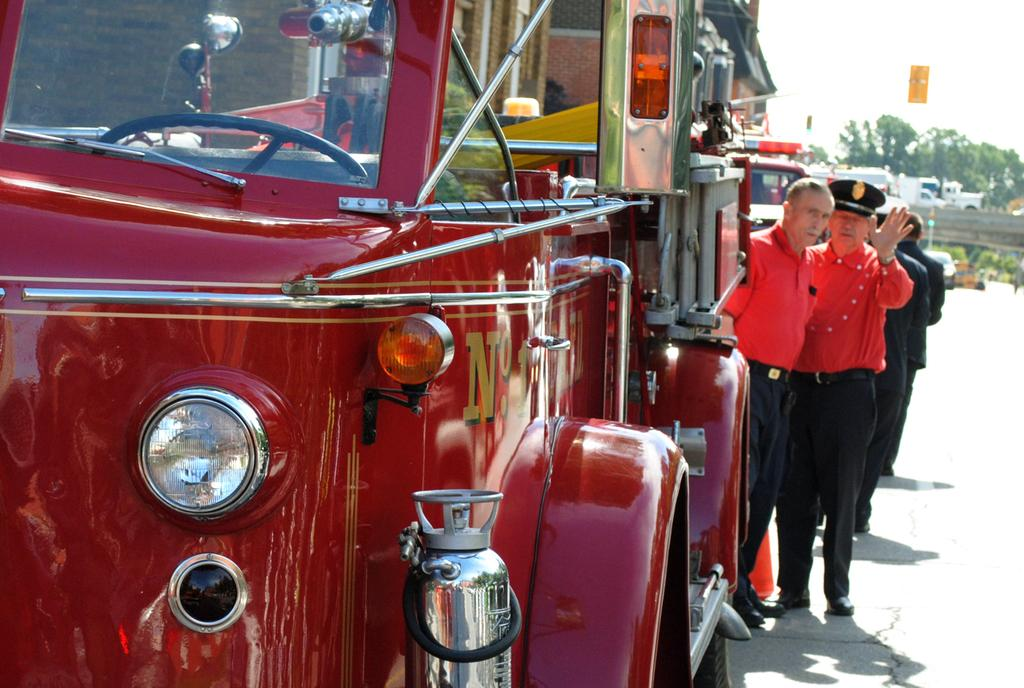Who or what can be seen in the image? There are people in the image. What are the people wearing? The people are wearing clothes. What else is present in the middle of the image? There are vehicles in the middle of the image. What type of natural elements can be seen in the top right of the image? There are trees in the top right of the image. What type of beetle can be seen crawling on the people's clothes in the image? There are no beetles present in the image; the people are wearing clothes, but no insects are visible. 